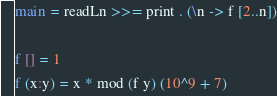<code> <loc_0><loc_0><loc_500><loc_500><_Haskell_>main = readLn >>= print . (\n -> f [2..n])

f [] = 1
f (x:y) = x * mod (f y) (10^9 + 7)</code> 